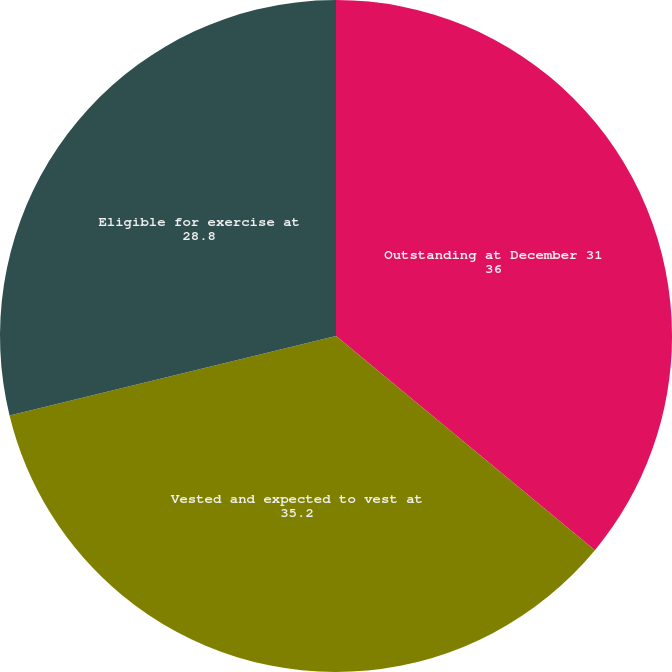<chart> <loc_0><loc_0><loc_500><loc_500><pie_chart><fcel>Outstanding at December 31<fcel>Vested and expected to vest at<fcel>Eligible for exercise at<nl><fcel>36.0%<fcel>35.2%<fcel>28.8%<nl></chart> 